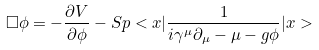<formula> <loc_0><loc_0><loc_500><loc_500>\Box \phi = - \frac { \partial V } { \partial \phi } - S p < x | \frac { 1 } { i \gamma ^ { \mu } \partial _ { \mu } - \mu - g \phi } | x ></formula> 